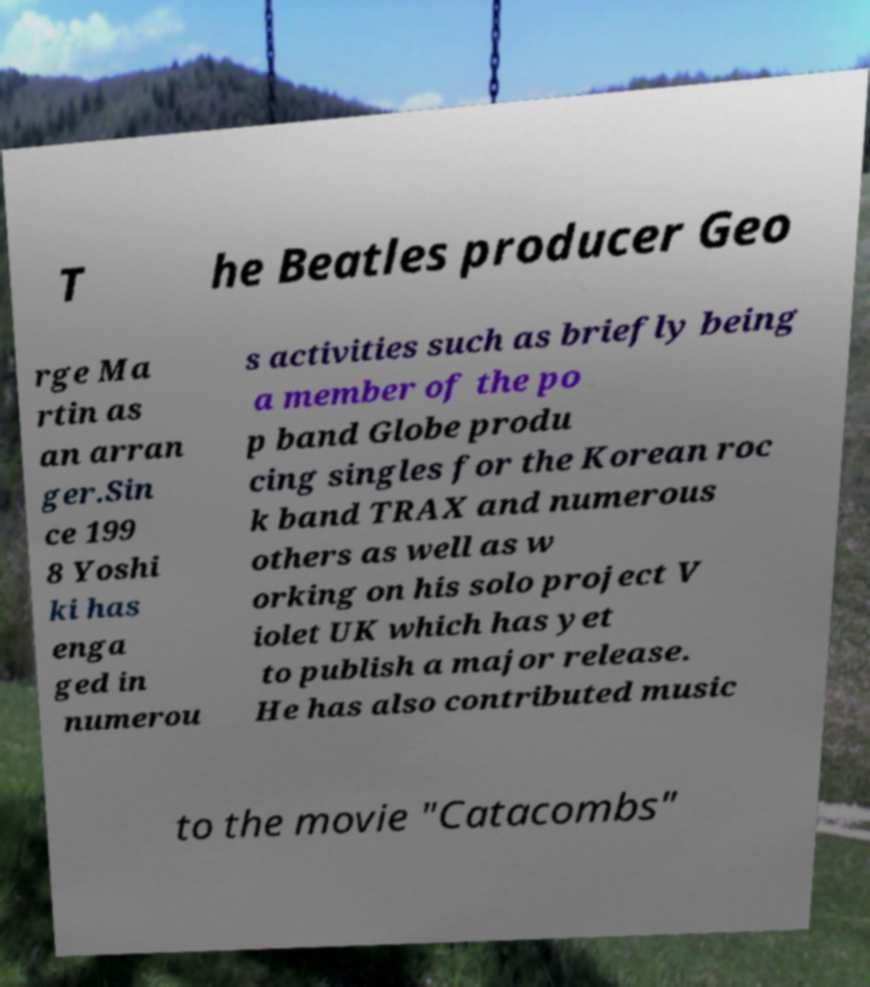Please read and relay the text visible in this image. What does it say? T he Beatles producer Geo rge Ma rtin as an arran ger.Sin ce 199 8 Yoshi ki has enga ged in numerou s activities such as briefly being a member of the po p band Globe produ cing singles for the Korean roc k band TRAX and numerous others as well as w orking on his solo project V iolet UK which has yet to publish a major release. He has also contributed music to the movie "Catacombs" 